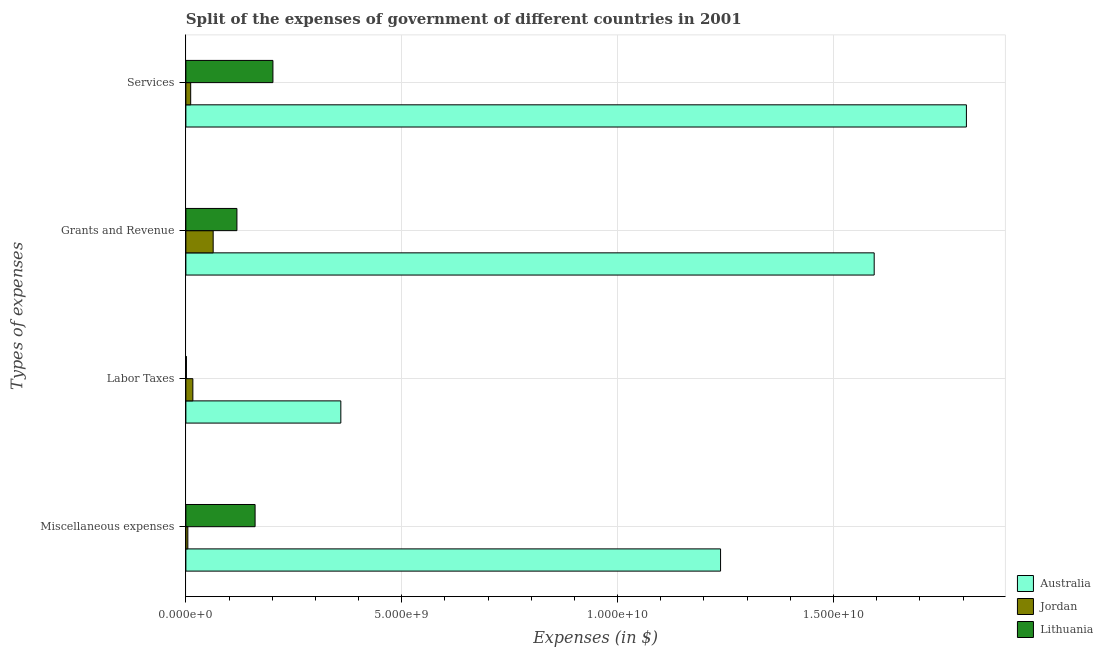How many different coloured bars are there?
Keep it short and to the point. 3. Are the number of bars per tick equal to the number of legend labels?
Offer a very short reply. Yes. What is the label of the 3rd group of bars from the top?
Offer a very short reply. Labor Taxes. What is the amount spent on services in Australia?
Offer a terse response. 1.81e+1. Across all countries, what is the maximum amount spent on labor taxes?
Give a very brief answer. 3.59e+09. Across all countries, what is the minimum amount spent on miscellaneous expenses?
Your answer should be very brief. 4.54e+07. In which country was the amount spent on grants and revenue minimum?
Make the answer very short. Jordan. What is the total amount spent on services in the graph?
Provide a short and direct response. 2.02e+1. What is the difference between the amount spent on services in Jordan and that in Australia?
Keep it short and to the point. -1.80e+1. What is the difference between the amount spent on grants and revenue in Lithuania and the amount spent on miscellaneous expenses in Jordan?
Offer a terse response. 1.14e+09. What is the average amount spent on miscellaneous expenses per country?
Keep it short and to the point. 4.68e+09. What is the difference between the amount spent on services and amount spent on labor taxes in Lithuania?
Offer a terse response. 2.00e+09. What is the ratio of the amount spent on labor taxes in Australia to that in Lithuania?
Your response must be concise. 296.61. Is the difference between the amount spent on grants and revenue in Jordan and Lithuania greater than the difference between the amount spent on labor taxes in Jordan and Lithuania?
Provide a succinct answer. No. What is the difference between the highest and the second highest amount spent on services?
Give a very brief answer. 1.61e+1. What is the difference between the highest and the lowest amount spent on miscellaneous expenses?
Ensure brevity in your answer.  1.23e+1. In how many countries, is the amount spent on miscellaneous expenses greater than the average amount spent on miscellaneous expenses taken over all countries?
Your response must be concise. 1. Is it the case that in every country, the sum of the amount spent on services and amount spent on grants and revenue is greater than the sum of amount spent on labor taxes and amount spent on miscellaneous expenses?
Your answer should be compact. Yes. What does the 2nd bar from the top in Services represents?
Your response must be concise. Jordan. What does the 2nd bar from the bottom in Grants and Revenue represents?
Your response must be concise. Jordan. How many bars are there?
Provide a succinct answer. 12. How many countries are there in the graph?
Offer a very short reply. 3. What is the difference between two consecutive major ticks on the X-axis?
Your answer should be very brief. 5.00e+09. Does the graph contain grids?
Your answer should be very brief. Yes. Where does the legend appear in the graph?
Your answer should be very brief. Bottom right. How are the legend labels stacked?
Ensure brevity in your answer.  Vertical. What is the title of the graph?
Keep it short and to the point. Split of the expenses of government of different countries in 2001. Does "Spain" appear as one of the legend labels in the graph?
Ensure brevity in your answer.  No. What is the label or title of the X-axis?
Offer a very short reply. Expenses (in $). What is the label or title of the Y-axis?
Make the answer very short. Types of expenses. What is the Expenses (in $) of Australia in Miscellaneous expenses?
Offer a terse response. 1.24e+1. What is the Expenses (in $) in Jordan in Miscellaneous expenses?
Provide a short and direct response. 4.54e+07. What is the Expenses (in $) of Lithuania in Miscellaneous expenses?
Your answer should be very brief. 1.60e+09. What is the Expenses (in $) of Australia in Labor Taxes?
Keep it short and to the point. 3.59e+09. What is the Expenses (in $) in Jordan in Labor Taxes?
Your answer should be compact. 1.62e+08. What is the Expenses (in $) of Lithuania in Labor Taxes?
Ensure brevity in your answer.  1.21e+07. What is the Expenses (in $) of Australia in Grants and Revenue?
Provide a succinct answer. 1.59e+1. What is the Expenses (in $) in Jordan in Grants and Revenue?
Your answer should be compact. 6.32e+08. What is the Expenses (in $) in Lithuania in Grants and Revenue?
Your answer should be compact. 1.18e+09. What is the Expenses (in $) in Australia in Services?
Provide a succinct answer. 1.81e+1. What is the Expenses (in $) in Jordan in Services?
Provide a short and direct response. 1.12e+08. What is the Expenses (in $) in Lithuania in Services?
Your answer should be compact. 2.02e+09. Across all Types of expenses, what is the maximum Expenses (in $) of Australia?
Provide a short and direct response. 1.81e+1. Across all Types of expenses, what is the maximum Expenses (in $) in Jordan?
Provide a succinct answer. 6.32e+08. Across all Types of expenses, what is the maximum Expenses (in $) of Lithuania?
Offer a terse response. 2.02e+09. Across all Types of expenses, what is the minimum Expenses (in $) of Australia?
Offer a very short reply. 3.59e+09. Across all Types of expenses, what is the minimum Expenses (in $) in Jordan?
Provide a short and direct response. 4.54e+07. Across all Types of expenses, what is the minimum Expenses (in $) of Lithuania?
Provide a short and direct response. 1.21e+07. What is the total Expenses (in $) in Australia in the graph?
Make the answer very short. 5.00e+1. What is the total Expenses (in $) in Jordan in the graph?
Keep it short and to the point. 9.51e+08. What is the total Expenses (in $) of Lithuania in the graph?
Your response must be concise. 4.81e+09. What is the difference between the Expenses (in $) of Australia in Miscellaneous expenses and that in Labor Taxes?
Provide a short and direct response. 8.80e+09. What is the difference between the Expenses (in $) in Jordan in Miscellaneous expenses and that in Labor Taxes?
Your response must be concise. -1.16e+08. What is the difference between the Expenses (in $) in Lithuania in Miscellaneous expenses and that in Labor Taxes?
Make the answer very short. 1.59e+09. What is the difference between the Expenses (in $) in Australia in Miscellaneous expenses and that in Grants and Revenue?
Provide a succinct answer. -3.56e+09. What is the difference between the Expenses (in $) of Jordan in Miscellaneous expenses and that in Grants and Revenue?
Ensure brevity in your answer.  -5.87e+08. What is the difference between the Expenses (in $) of Lithuania in Miscellaneous expenses and that in Grants and Revenue?
Ensure brevity in your answer.  4.21e+08. What is the difference between the Expenses (in $) of Australia in Miscellaneous expenses and that in Services?
Offer a very short reply. -5.69e+09. What is the difference between the Expenses (in $) of Jordan in Miscellaneous expenses and that in Services?
Your response must be concise. -6.62e+07. What is the difference between the Expenses (in $) of Lithuania in Miscellaneous expenses and that in Services?
Provide a short and direct response. -4.13e+08. What is the difference between the Expenses (in $) in Australia in Labor Taxes and that in Grants and Revenue?
Your answer should be compact. -1.24e+1. What is the difference between the Expenses (in $) of Jordan in Labor Taxes and that in Grants and Revenue?
Offer a very short reply. -4.70e+08. What is the difference between the Expenses (in $) of Lithuania in Labor Taxes and that in Grants and Revenue?
Your answer should be compact. -1.17e+09. What is the difference between the Expenses (in $) of Australia in Labor Taxes and that in Services?
Keep it short and to the point. -1.45e+1. What is the difference between the Expenses (in $) of Jordan in Labor Taxes and that in Services?
Keep it short and to the point. 5.03e+07. What is the difference between the Expenses (in $) of Lithuania in Labor Taxes and that in Services?
Your answer should be very brief. -2.00e+09. What is the difference between the Expenses (in $) in Australia in Grants and Revenue and that in Services?
Your answer should be very brief. -2.14e+09. What is the difference between the Expenses (in $) of Jordan in Grants and Revenue and that in Services?
Your answer should be compact. 5.21e+08. What is the difference between the Expenses (in $) of Lithuania in Grants and Revenue and that in Services?
Give a very brief answer. -8.34e+08. What is the difference between the Expenses (in $) in Australia in Miscellaneous expenses and the Expenses (in $) in Jordan in Labor Taxes?
Provide a short and direct response. 1.22e+1. What is the difference between the Expenses (in $) of Australia in Miscellaneous expenses and the Expenses (in $) of Lithuania in Labor Taxes?
Make the answer very short. 1.24e+1. What is the difference between the Expenses (in $) of Jordan in Miscellaneous expenses and the Expenses (in $) of Lithuania in Labor Taxes?
Your response must be concise. 3.33e+07. What is the difference between the Expenses (in $) of Australia in Miscellaneous expenses and the Expenses (in $) of Jordan in Grants and Revenue?
Your response must be concise. 1.18e+1. What is the difference between the Expenses (in $) of Australia in Miscellaneous expenses and the Expenses (in $) of Lithuania in Grants and Revenue?
Offer a very short reply. 1.12e+1. What is the difference between the Expenses (in $) of Jordan in Miscellaneous expenses and the Expenses (in $) of Lithuania in Grants and Revenue?
Offer a terse response. -1.14e+09. What is the difference between the Expenses (in $) in Australia in Miscellaneous expenses and the Expenses (in $) in Jordan in Services?
Offer a terse response. 1.23e+1. What is the difference between the Expenses (in $) of Australia in Miscellaneous expenses and the Expenses (in $) of Lithuania in Services?
Offer a terse response. 1.04e+1. What is the difference between the Expenses (in $) of Jordan in Miscellaneous expenses and the Expenses (in $) of Lithuania in Services?
Keep it short and to the point. -1.97e+09. What is the difference between the Expenses (in $) in Australia in Labor Taxes and the Expenses (in $) in Jordan in Grants and Revenue?
Your answer should be compact. 2.96e+09. What is the difference between the Expenses (in $) in Australia in Labor Taxes and the Expenses (in $) in Lithuania in Grants and Revenue?
Ensure brevity in your answer.  2.41e+09. What is the difference between the Expenses (in $) of Jordan in Labor Taxes and the Expenses (in $) of Lithuania in Grants and Revenue?
Ensure brevity in your answer.  -1.02e+09. What is the difference between the Expenses (in $) of Australia in Labor Taxes and the Expenses (in $) of Jordan in Services?
Provide a succinct answer. 3.48e+09. What is the difference between the Expenses (in $) in Australia in Labor Taxes and the Expenses (in $) in Lithuania in Services?
Provide a succinct answer. 1.57e+09. What is the difference between the Expenses (in $) of Jordan in Labor Taxes and the Expenses (in $) of Lithuania in Services?
Offer a terse response. -1.85e+09. What is the difference between the Expenses (in $) in Australia in Grants and Revenue and the Expenses (in $) in Jordan in Services?
Ensure brevity in your answer.  1.58e+1. What is the difference between the Expenses (in $) in Australia in Grants and Revenue and the Expenses (in $) in Lithuania in Services?
Provide a succinct answer. 1.39e+1. What is the difference between the Expenses (in $) of Jordan in Grants and Revenue and the Expenses (in $) of Lithuania in Services?
Your response must be concise. -1.38e+09. What is the average Expenses (in $) of Australia per Types of expenses?
Your answer should be very brief. 1.25e+1. What is the average Expenses (in $) of Jordan per Types of expenses?
Make the answer very short. 2.38e+08. What is the average Expenses (in $) of Lithuania per Types of expenses?
Your response must be concise. 1.20e+09. What is the difference between the Expenses (in $) of Australia and Expenses (in $) of Jordan in Miscellaneous expenses?
Keep it short and to the point. 1.23e+1. What is the difference between the Expenses (in $) of Australia and Expenses (in $) of Lithuania in Miscellaneous expenses?
Keep it short and to the point. 1.08e+1. What is the difference between the Expenses (in $) in Jordan and Expenses (in $) in Lithuania in Miscellaneous expenses?
Your answer should be compact. -1.56e+09. What is the difference between the Expenses (in $) in Australia and Expenses (in $) in Jordan in Labor Taxes?
Give a very brief answer. 3.43e+09. What is the difference between the Expenses (in $) of Australia and Expenses (in $) of Lithuania in Labor Taxes?
Give a very brief answer. 3.58e+09. What is the difference between the Expenses (in $) in Jordan and Expenses (in $) in Lithuania in Labor Taxes?
Offer a terse response. 1.50e+08. What is the difference between the Expenses (in $) of Australia and Expenses (in $) of Jordan in Grants and Revenue?
Your answer should be very brief. 1.53e+1. What is the difference between the Expenses (in $) of Australia and Expenses (in $) of Lithuania in Grants and Revenue?
Your response must be concise. 1.48e+1. What is the difference between the Expenses (in $) of Jordan and Expenses (in $) of Lithuania in Grants and Revenue?
Offer a terse response. -5.50e+08. What is the difference between the Expenses (in $) of Australia and Expenses (in $) of Jordan in Services?
Your answer should be very brief. 1.80e+1. What is the difference between the Expenses (in $) of Australia and Expenses (in $) of Lithuania in Services?
Your answer should be very brief. 1.61e+1. What is the difference between the Expenses (in $) in Jordan and Expenses (in $) in Lithuania in Services?
Offer a very short reply. -1.90e+09. What is the ratio of the Expenses (in $) in Australia in Miscellaneous expenses to that in Labor Taxes?
Offer a very short reply. 3.45. What is the ratio of the Expenses (in $) in Jordan in Miscellaneous expenses to that in Labor Taxes?
Keep it short and to the point. 0.28. What is the ratio of the Expenses (in $) of Lithuania in Miscellaneous expenses to that in Labor Taxes?
Offer a very short reply. 132.48. What is the ratio of the Expenses (in $) in Australia in Miscellaneous expenses to that in Grants and Revenue?
Give a very brief answer. 0.78. What is the ratio of the Expenses (in $) in Jordan in Miscellaneous expenses to that in Grants and Revenue?
Provide a short and direct response. 0.07. What is the ratio of the Expenses (in $) of Lithuania in Miscellaneous expenses to that in Grants and Revenue?
Your answer should be compact. 1.36. What is the ratio of the Expenses (in $) of Australia in Miscellaneous expenses to that in Services?
Your answer should be very brief. 0.69. What is the ratio of the Expenses (in $) of Jordan in Miscellaneous expenses to that in Services?
Ensure brevity in your answer.  0.41. What is the ratio of the Expenses (in $) of Lithuania in Miscellaneous expenses to that in Services?
Provide a short and direct response. 0.8. What is the ratio of the Expenses (in $) in Australia in Labor Taxes to that in Grants and Revenue?
Give a very brief answer. 0.23. What is the ratio of the Expenses (in $) of Jordan in Labor Taxes to that in Grants and Revenue?
Your answer should be compact. 0.26. What is the ratio of the Expenses (in $) in Lithuania in Labor Taxes to that in Grants and Revenue?
Offer a terse response. 0.01. What is the ratio of the Expenses (in $) of Australia in Labor Taxes to that in Services?
Ensure brevity in your answer.  0.2. What is the ratio of the Expenses (in $) in Jordan in Labor Taxes to that in Services?
Keep it short and to the point. 1.45. What is the ratio of the Expenses (in $) of Lithuania in Labor Taxes to that in Services?
Ensure brevity in your answer.  0.01. What is the ratio of the Expenses (in $) of Australia in Grants and Revenue to that in Services?
Make the answer very short. 0.88. What is the ratio of the Expenses (in $) of Jordan in Grants and Revenue to that in Services?
Provide a succinct answer. 5.67. What is the ratio of the Expenses (in $) of Lithuania in Grants and Revenue to that in Services?
Give a very brief answer. 0.59. What is the difference between the highest and the second highest Expenses (in $) of Australia?
Offer a very short reply. 2.14e+09. What is the difference between the highest and the second highest Expenses (in $) in Jordan?
Your response must be concise. 4.70e+08. What is the difference between the highest and the second highest Expenses (in $) of Lithuania?
Offer a terse response. 4.13e+08. What is the difference between the highest and the lowest Expenses (in $) of Australia?
Your answer should be compact. 1.45e+1. What is the difference between the highest and the lowest Expenses (in $) of Jordan?
Offer a terse response. 5.87e+08. What is the difference between the highest and the lowest Expenses (in $) of Lithuania?
Offer a terse response. 2.00e+09. 